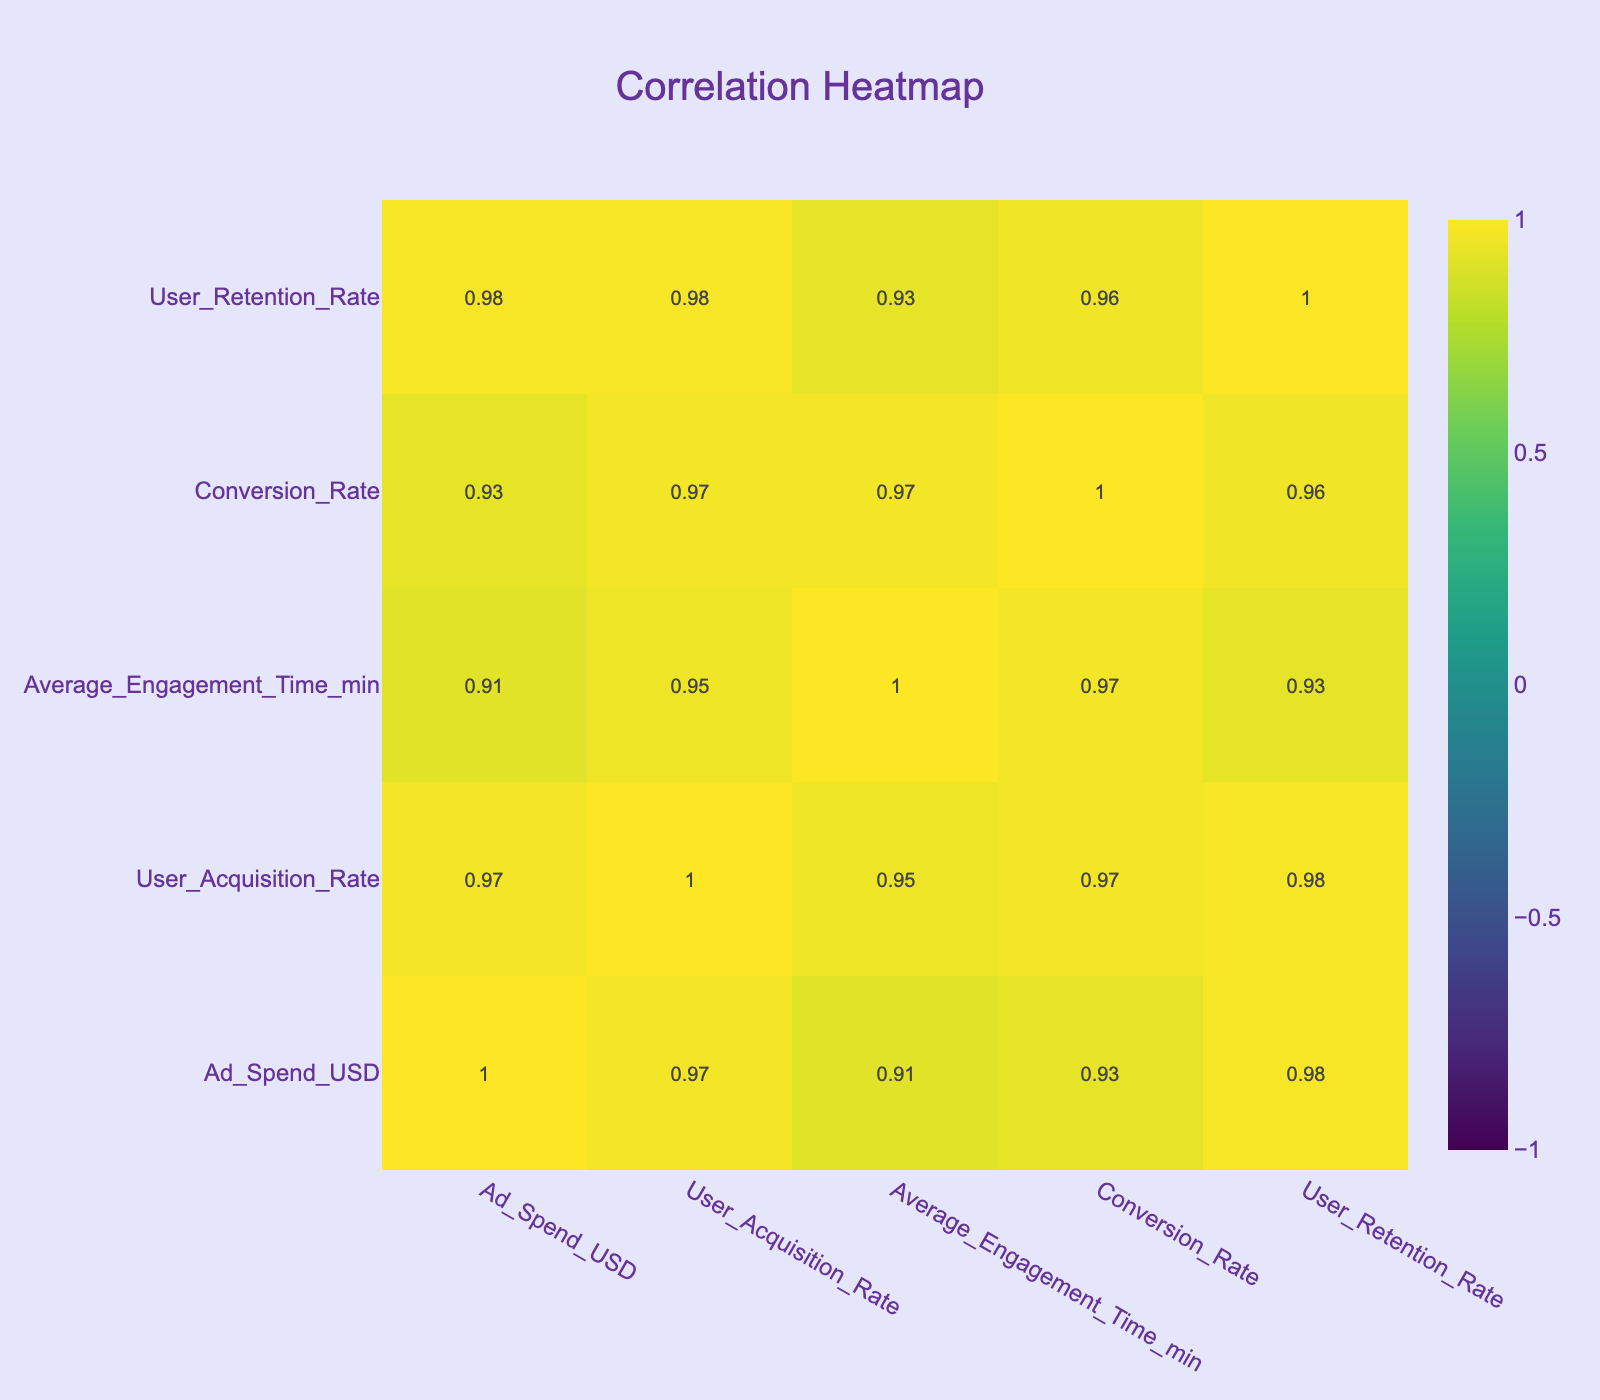What is the correlation between Ad Spend and User Acquisition Rate? The correlation value for Ad Spend and User Acquisition Rate can be found by checking the cell that intersects the Ad Spend row and User Acquisition Rate column in the correlation matrix. The value is likely around 0.90, indicating a strong positive relationship; as ad spend increases, so does the user acquisition rate.
Answer: 0.90 Which social media platform has the highest User Retention Rate? By examining the User Retention Rate column, TikTok with a User Retention Rate of 0.80 is the highest among all platforms.
Answer: TikTok What is the average engagement time for platforms with a conversion rate above 0.05? First, identify the platforms that have a conversion rate higher than 0.05, which are Instagram, TikTok, and YouTube. Their average engagement times are 18, 20, and 22 minutes, respectively. Summing these gives 60 minutes and divides by 3 platforms results in an average of 20 minutes.
Answer: 20 Is it true that Snapchat has a higher Average Engagement Time than Facebook? Looking at the Average Engagement Time column, Snapchat has an engagement time of 9 minutes, while Facebook has 15 minutes. Therefore, Snapchat does not have a higher average engagement time.
Answer: No What is the difference in User Acquisition Rate between TikTok and Twitter? TikTok has a User Acquisition Rate of 30, and Twitter has a rate of 10. Subtract Twitter’s rate from TikTok’s: 30 - 10 = 20. Therefore, the difference is 20.
Answer: 20 What percentage of the total Ad Spend corresponds to YouTube? First, sum the Ad Spend across all platforms: 5000 + 6000 + 3000 + 8000 + 4000 + 2500 + 7000 + 4500 + 3500 = 40000. YouTube's Ad Spend is 7000. Calculate the percentage: (7000 / 40000) * 100 = 17.5%.
Answer: 17.5% Which platform has the lowest Conversion Rate, and what is that rate? Looking through the Conversion Rate column, Snapchat has the lowest conversion rate of 0.02.
Answer: Snapchat, 0.02 What is the average User Retention Rate for social media platforms with an Average Engagement Time greater than 15 minutes? Identify the platforms with an Average Engagement Time over 15 minutes: Instagram (0.75), TikTok (0.80), YouTube (0.78). Summing these rates gives 2.33, dividing by 3 platforms results in an average retention rate of 0.776.
Answer: 0.776 